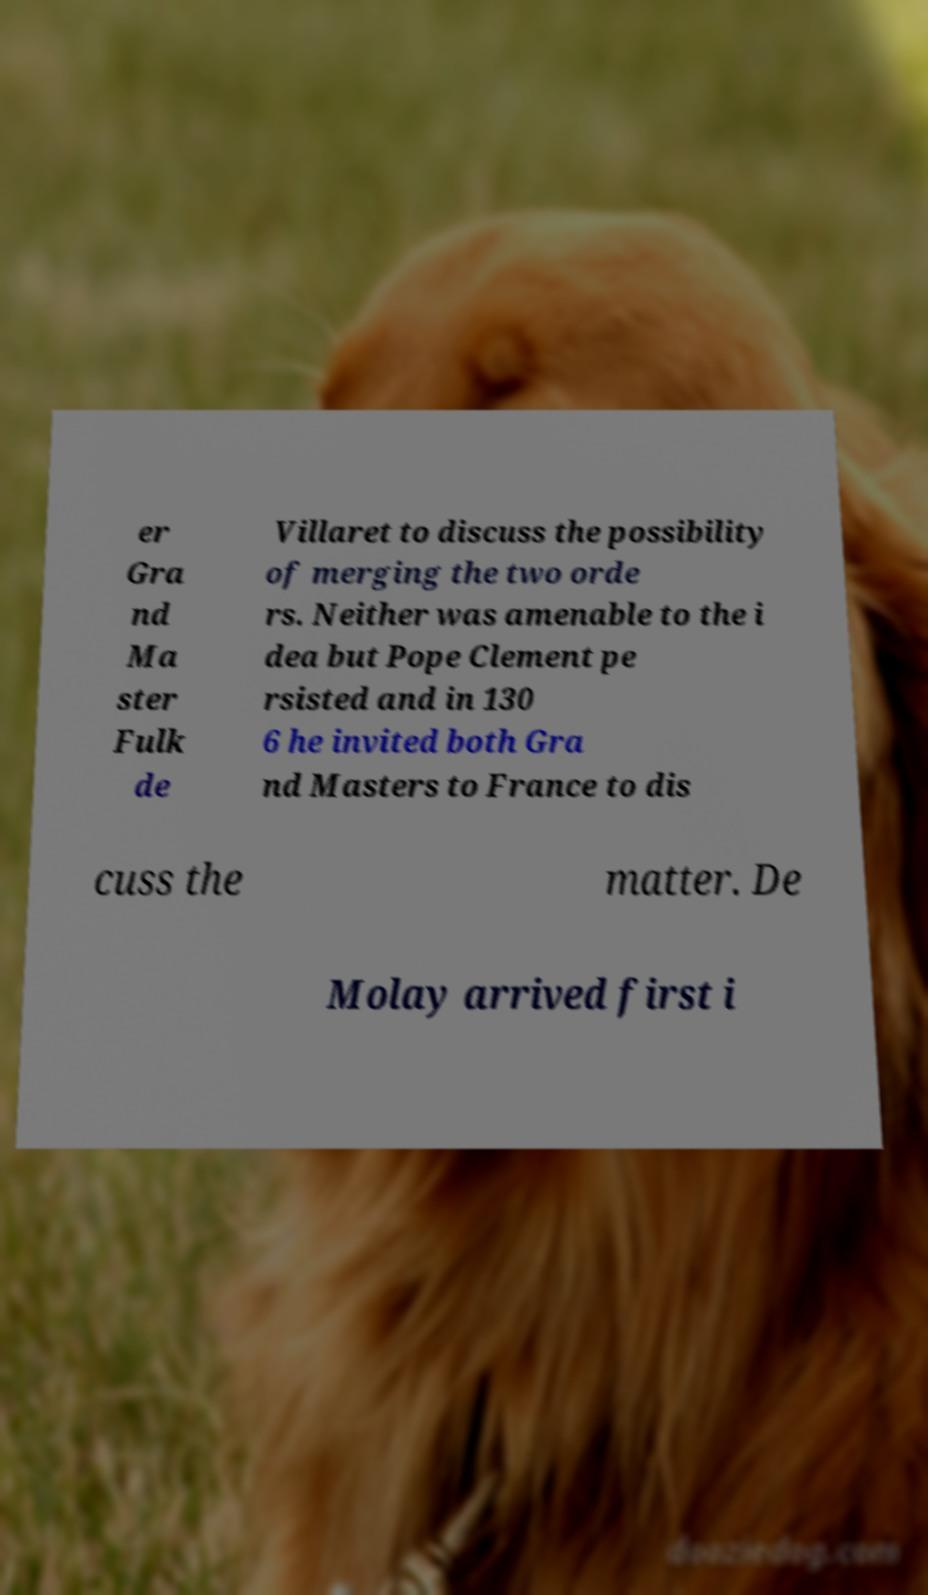What messages or text are displayed in this image? I need them in a readable, typed format. er Gra nd Ma ster Fulk de Villaret to discuss the possibility of merging the two orde rs. Neither was amenable to the i dea but Pope Clement pe rsisted and in 130 6 he invited both Gra nd Masters to France to dis cuss the matter. De Molay arrived first i 